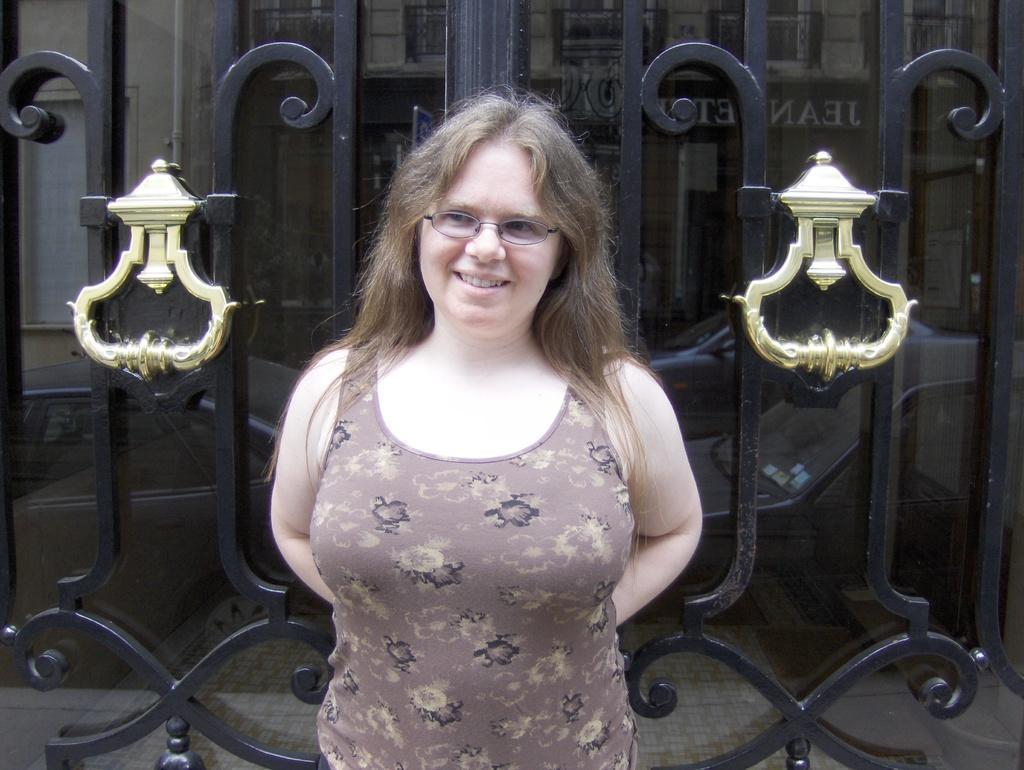Can you describe this image briefly? In this image I can see a person standing wearing brown color shirt, background I can see a gate in black color and a building in gray color. 